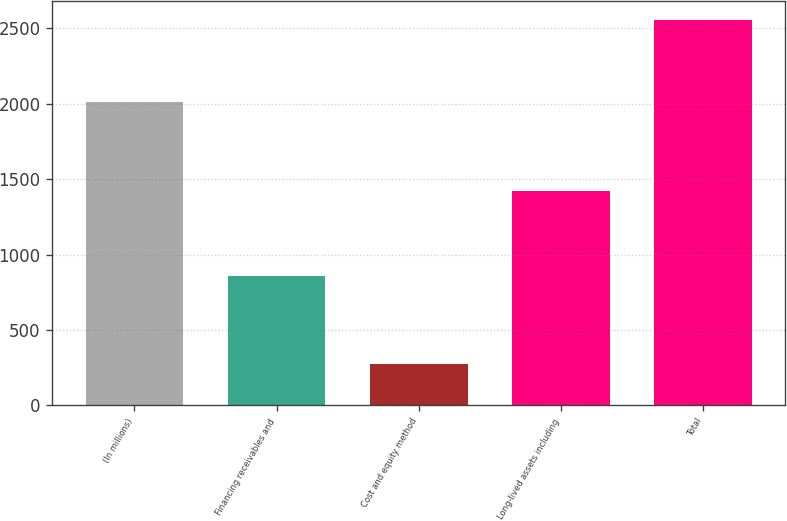Convert chart to OTSL. <chart><loc_0><loc_0><loc_500><loc_500><bar_chart><fcel>(In millions)<fcel>Financing receivables and<fcel>Cost and equity method<fcel>Long-lived assets including<fcel>Total<nl><fcel>2011<fcel>857<fcel>274<fcel>1424<fcel>2555<nl></chart> 